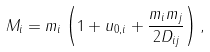Convert formula to latex. <formula><loc_0><loc_0><loc_500><loc_500>M _ { i } = m _ { i } \left ( 1 + u _ { 0 , i } + \frac { m _ { i } m _ { j } } { 2 D _ { i j } } \right ) ,</formula> 